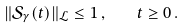Convert formula to latex. <formula><loc_0><loc_0><loc_500><loc_500>\| \mathcal { S } _ { \gamma } ( t ) \| _ { \mathcal { L } } \leq 1 \, , \quad t \geq 0 \, .</formula> 